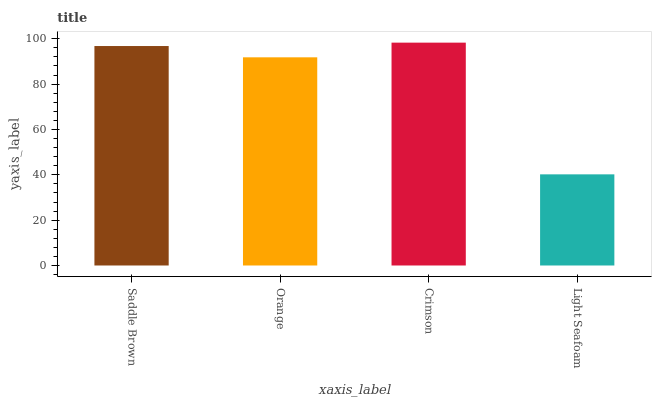Is Light Seafoam the minimum?
Answer yes or no. Yes. Is Crimson the maximum?
Answer yes or no. Yes. Is Orange the minimum?
Answer yes or no. No. Is Orange the maximum?
Answer yes or no. No. Is Saddle Brown greater than Orange?
Answer yes or no. Yes. Is Orange less than Saddle Brown?
Answer yes or no. Yes. Is Orange greater than Saddle Brown?
Answer yes or no. No. Is Saddle Brown less than Orange?
Answer yes or no. No. Is Saddle Brown the high median?
Answer yes or no. Yes. Is Orange the low median?
Answer yes or no. Yes. Is Orange the high median?
Answer yes or no. No. Is Saddle Brown the low median?
Answer yes or no. No. 